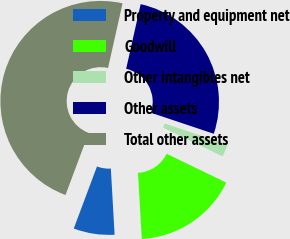Convert chart to OTSL. <chart><loc_0><loc_0><loc_500><loc_500><pie_chart><fcel>Property and equipment net<fcel>Goodwill<fcel>Other intangibles net<fcel>Other assets<fcel>Total other assets<nl><fcel>6.61%<fcel>16.91%<fcel>2.04%<fcel>26.63%<fcel>47.81%<nl></chart> 